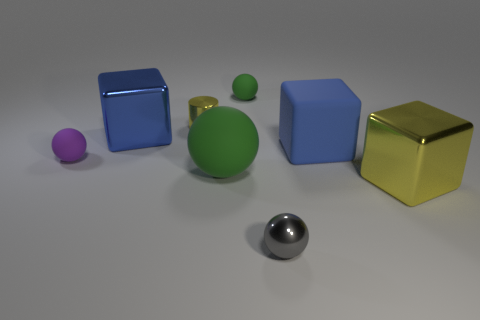How many green balls must be subtracted to get 1 green balls? 1 Subtract 1 balls. How many balls are left? 3 Add 1 purple blocks. How many objects exist? 9 Subtract all cubes. How many objects are left? 5 Subtract 0 cyan spheres. How many objects are left? 8 Subtract all blue metallic blocks. Subtract all tiny rubber things. How many objects are left? 5 Add 6 blue metallic blocks. How many blue metallic blocks are left? 7 Add 2 purple blocks. How many purple blocks exist? 2 